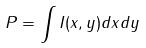Convert formula to latex. <formula><loc_0><loc_0><loc_500><loc_500>P = \int I ( x , y ) d x d y</formula> 